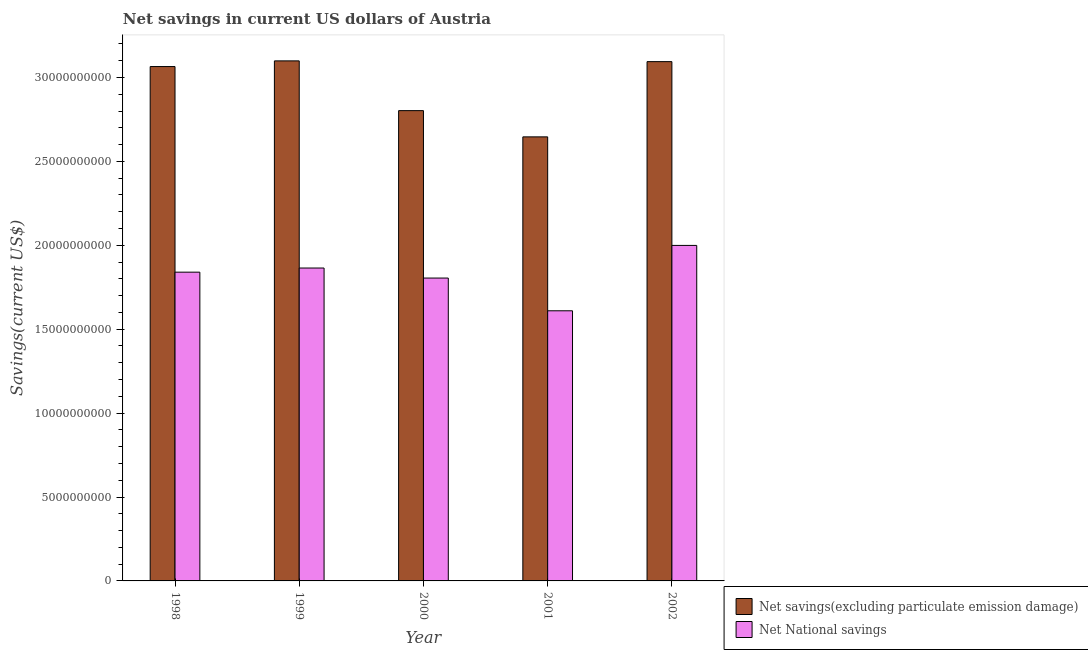Are the number of bars on each tick of the X-axis equal?
Ensure brevity in your answer.  Yes. How many bars are there on the 1st tick from the right?
Provide a succinct answer. 2. In how many cases, is the number of bars for a given year not equal to the number of legend labels?
Offer a terse response. 0. What is the net savings(excluding particulate emission damage) in 2000?
Provide a short and direct response. 2.80e+1. Across all years, what is the maximum net national savings?
Provide a succinct answer. 2.00e+1. Across all years, what is the minimum net savings(excluding particulate emission damage)?
Offer a terse response. 2.65e+1. What is the total net savings(excluding particulate emission damage) in the graph?
Offer a very short reply. 1.47e+11. What is the difference between the net savings(excluding particulate emission damage) in 1998 and that in 1999?
Ensure brevity in your answer.  -3.38e+08. What is the difference between the net national savings in 2000 and the net savings(excluding particulate emission damage) in 1999?
Offer a terse response. -5.98e+08. What is the average net savings(excluding particulate emission damage) per year?
Provide a short and direct response. 2.94e+1. In how many years, is the net national savings greater than 18000000000 US$?
Keep it short and to the point. 4. What is the ratio of the net savings(excluding particulate emission damage) in 1998 to that in 2002?
Your answer should be compact. 0.99. Is the net national savings in 1999 less than that in 2000?
Your answer should be compact. No. Is the difference between the net national savings in 1999 and 2000 greater than the difference between the net savings(excluding particulate emission damage) in 1999 and 2000?
Your answer should be very brief. No. What is the difference between the highest and the second highest net savings(excluding particulate emission damage)?
Your response must be concise. 4.53e+07. What is the difference between the highest and the lowest net savings(excluding particulate emission damage)?
Your response must be concise. 4.53e+09. Is the sum of the net savings(excluding particulate emission damage) in 1998 and 2001 greater than the maximum net national savings across all years?
Your answer should be compact. Yes. What does the 1st bar from the left in 2002 represents?
Make the answer very short. Net savings(excluding particulate emission damage). What does the 1st bar from the right in 1999 represents?
Provide a short and direct response. Net National savings. How many years are there in the graph?
Provide a short and direct response. 5. What is the difference between two consecutive major ticks on the Y-axis?
Provide a short and direct response. 5.00e+09. How are the legend labels stacked?
Provide a succinct answer. Vertical. What is the title of the graph?
Ensure brevity in your answer.  Net savings in current US dollars of Austria. Does "Non-solid fuel" appear as one of the legend labels in the graph?
Your response must be concise. No. What is the label or title of the X-axis?
Your response must be concise. Year. What is the label or title of the Y-axis?
Offer a very short reply. Savings(current US$). What is the Savings(current US$) in Net savings(excluding particulate emission damage) in 1998?
Provide a succinct answer. 3.07e+1. What is the Savings(current US$) in Net National savings in 1998?
Ensure brevity in your answer.  1.84e+1. What is the Savings(current US$) in Net savings(excluding particulate emission damage) in 1999?
Keep it short and to the point. 3.10e+1. What is the Savings(current US$) in Net National savings in 1999?
Your response must be concise. 1.86e+1. What is the Savings(current US$) in Net savings(excluding particulate emission damage) in 2000?
Your answer should be compact. 2.80e+1. What is the Savings(current US$) in Net National savings in 2000?
Provide a succinct answer. 1.80e+1. What is the Savings(current US$) in Net savings(excluding particulate emission damage) in 2001?
Provide a succinct answer. 2.65e+1. What is the Savings(current US$) of Net National savings in 2001?
Provide a short and direct response. 1.61e+1. What is the Savings(current US$) in Net savings(excluding particulate emission damage) in 2002?
Provide a short and direct response. 3.09e+1. What is the Savings(current US$) of Net National savings in 2002?
Keep it short and to the point. 2.00e+1. Across all years, what is the maximum Savings(current US$) of Net savings(excluding particulate emission damage)?
Offer a very short reply. 3.10e+1. Across all years, what is the maximum Savings(current US$) in Net National savings?
Offer a terse response. 2.00e+1. Across all years, what is the minimum Savings(current US$) in Net savings(excluding particulate emission damage)?
Keep it short and to the point. 2.65e+1. Across all years, what is the minimum Savings(current US$) of Net National savings?
Give a very brief answer. 1.61e+1. What is the total Savings(current US$) in Net savings(excluding particulate emission damage) in the graph?
Offer a terse response. 1.47e+11. What is the total Savings(current US$) of Net National savings in the graph?
Your response must be concise. 9.12e+1. What is the difference between the Savings(current US$) in Net savings(excluding particulate emission damage) in 1998 and that in 1999?
Keep it short and to the point. -3.38e+08. What is the difference between the Savings(current US$) in Net National savings in 1998 and that in 1999?
Your answer should be compact. -2.46e+08. What is the difference between the Savings(current US$) of Net savings(excluding particulate emission damage) in 1998 and that in 2000?
Keep it short and to the point. 2.63e+09. What is the difference between the Savings(current US$) of Net National savings in 1998 and that in 2000?
Provide a succinct answer. 3.51e+08. What is the difference between the Savings(current US$) in Net savings(excluding particulate emission damage) in 1998 and that in 2001?
Offer a terse response. 4.19e+09. What is the difference between the Savings(current US$) in Net National savings in 1998 and that in 2001?
Provide a succinct answer. 2.30e+09. What is the difference between the Savings(current US$) of Net savings(excluding particulate emission damage) in 1998 and that in 2002?
Your answer should be compact. -2.93e+08. What is the difference between the Savings(current US$) of Net National savings in 1998 and that in 2002?
Make the answer very short. -1.59e+09. What is the difference between the Savings(current US$) in Net savings(excluding particulate emission damage) in 1999 and that in 2000?
Make the answer very short. 2.96e+09. What is the difference between the Savings(current US$) of Net National savings in 1999 and that in 2000?
Offer a very short reply. 5.98e+08. What is the difference between the Savings(current US$) in Net savings(excluding particulate emission damage) in 1999 and that in 2001?
Your answer should be very brief. 4.53e+09. What is the difference between the Savings(current US$) in Net National savings in 1999 and that in 2001?
Make the answer very short. 2.55e+09. What is the difference between the Savings(current US$) of Net savings(excluding particulate emission damage) in 1999 and that in 2002?
Ensure brevity in your answer.  4.53e+07. What is the difference between the Savings(current US$) in Net National savings in 1999 and that in 2002?
Provide a succinct answer. -1.35e+09. What is the difference between the Savings(current US$) of Net savings(excluding particulate emission damage) in 2000 and that in 2001?
Ensure brevity in your answer.  1.56e+09. What is the difference between the Savings(current US$) in Net National savings in 2000 and that in 2001?
Offer a terse response. 1.95e+09. What is the difference between the Savings(current US$) of Net savings(excluding particulate emission damage) in 2000 and that in 2002?
Keep it short and to the point. -2.92e+09. What is the difference between the Savings(current US$) of Net National savings in 2000 and that in 2002?
Your answer should be very brief. -1.95e+09. What is the difference between the Savings(current US$) in Net savings(excluding particulate emission damage) in 2001 and that in 2002?
Offer a very short reply. -4.48e+09. What is the difference between the Savings(current US$) in Net National savings in 2001 and that in 2002?
Provide a succinct answer. -3.90e+09. What is the difference between the Savings(current US$) in Net savings(excluding particulate emission damage) in 1998 and the Savings(current US$) in Net National savings in 1999?
Offer a terse response. 1.20e+1. What is the difference between the Savings(current US$) of Net savings(excluding particulate emission damage) in 1998 and the Savings(current US$) of Net National savings in 2000?
Ensure brevity in your answer.  1.26e+1. What is the difference between the Savings(current US$) in Net savings(excluding particulate emission damage) in 1998 and the Savings(current US$) in Net National savings in 2001?
Keep it short and to the point. 1.46e+1. What is the difference between the Savings(current US$) of Net savings(excluding particulate emission damage) in 1998 and the Savings(current US$) of Net National savings in 2002?
Make the answer very short. 1.07e+1. What is the difference between the Savings(current US$) of Net savings(excluding particulate emission damage) in 1999 and the Savings(current US$) of Net National savings in 2000?
Make the answer very short. 1.29e+1. What is the difference between the Savings(current US$) of Net savings(excluding particulate emission damage) in 1999 and the Savings(current US$) of Net National savings in 2001?
Give a very brief answer. 1.49e+1. What is the difference between the Savings(current US$) of Net savings(excluding particulate emission damage) in 1999 and the Savings(current US$) of Net National savings in 2002?
Provide a succinct answer. 1.10e+1. What is the difference between the Savings(current US$) of Net savings(excluding particulate emission damage) in 2000 and the Savings(current US$) of Net National savings in 2001?
Your answer should be very brief. 1.19e+1. What is the difference between the Savings(current US$) of Net savings(excluding particulate emission damage) in 2000 and the Savings(current US$) of Net National savings in 2002?
Offer a terse response. 8.03e+09. What is the difference between the Savings(current US$) of Net savings(excluding particulate emission damage) in 2001 and the Savings(current US$) of Net National savings in 2002?
Ensure brevity in your answer.  6.47e+09. What is the average Savings(current US$) in Net savings(excluding particulate emission damage) per year?
Provide a short and direct response. 2.94e+1. What is the average Savings(current US$) of Net National savings per year?
Keep it short and to the point. 1.82e+1. In the year 1998, what is the difference between the Savings(current US$) in Net savings(excluding particulate emission damage) and Savings(current US$) in Net National savings?
Your response must be concise. 1.23e+1. In the year 1999, what is the difference between the Savings(current US$) of Net savings(excluding particulate emission damage) and Savings(current US$) of Net National savings?
Provide a succinct answer. 1.23e+1. In the year 2000, what is the difference between the Savings(current US$) of Net savings(excluding particulate emission damage) and Savings(current US$) of Net National savings?
Make the answer very short. 9.98e+09. In the year 2001, what is the difference between the Savings(current US$) in Net savings(excluding particulate emission damage) and Savings(current US$) in Net National savings?
Provide a succinct answer. 1.04e+1. In the year 2002, what is the difference between the Savings(current US$) of Net savings(excluding particulate emission damage) and Savings(current US$) of Net National savings?
Offer a very short reply. 1.10e+1. What is the ratio of the Savings(current US$) of Net savings(excluding particulate emission damage) in 1998 to that in 2000?
Your answer should be compact. 1.09. What is the ratio of the Savings(current US$) in Net National savings in 1998 to that in 2000?
Keep it short and to the point. 1.02. What is the ratio of the Savings(current US$) in Net savings(excluding particulate emission damage) in 1998 to that in 2001?
Keep it short and to the point. 1.16. What is the ratio of the Savings(current US$) in Net National savings in 1998 to that in 2001?
Provide a short and direct response. 1.14. What is the ratio of the Savings(current US$) of Net savings(excluding particulate emission damage) in 1998 to that in 2002?
Your answer should be very brief. 0.99. What is the ratio of the Savings(current US$) of Net National savings in 1998 to that in 2002?
Provide a short and direct response. 0.92. What is the ratio of the Savings(current US$) in Net savings(excluding particulate emission damage) in 1999 to that in 2000?
Your response must be concise. 1.11. What is the ratio of the Savings(current US$) of Net National savings in 1999 to that in 2000?
Keep it short and to the point. 1.03. What is the ratio of the Savings(current US$) of Net savings(excluding particulate emission damage) in 1999 to that in 2001?
Your answer should be compact. 1.17. What is the ratio of the Savings(current US$) of Net National savings in 1999 to that in 2001?
Offer a terse response. 1.16. What is the ratio of the Savings(current US$) in Net savings(excluding particulate emission damage) in 1999 to that in 2002?
Make the answer very short. 1. What is the ratio of the Savings(current US$) of Net National savings in 1999 to that in 2002?
Provide a short and direct response. 0.93. What is the ratio of the Savings(current US$) in Net savings(excluding particulate emission damage) in 2000 to that in 2001?
Your response must be concise. 1.06. What is the ratio of the Savings(current US$) of Net National savings in 2000 to that in 2001?
Ensure brevity in your answer.  1.12. What is the ratio of the Savings(current US$) of Net savings(excluding particulate emission damage) in 2000 to that in 2002?
Your response must be concise. 0.91. What is the ratio of the Savings(current US$) in Net National savings in 2000 to that in 2002?
Provide a succinct answer. 0.9. What is the ratio of the Savings(current US$) in Net savings(excluding particulate emission damage) in 2001 to that in 2002?
Keep it short and to the point. 0.86. What is the ratio of the Savings(current US$) in Net National savings in 2001 to that in 2002?
Offer a terse response. 0.81. What is the difference between the highest and the second highest Savings(current US$) in Net savings(excluding particulate emission damage)?
Give a very brief answer. 4.53e+07. What is the difference between the highest and the second highest Savings(current US$) in Net National savings?
Keep it short and to the point. 1.35e+09. What is the difference between the highest and the lowest Savings(current US$) of Net savings(excluding particulate emission damage)?
Provide a short and direct response. 4.53e+09. What is the difference between the highest and the lowest Savings(current US$) of Net National savings?
Your response must be concise. 3.90e+09. 